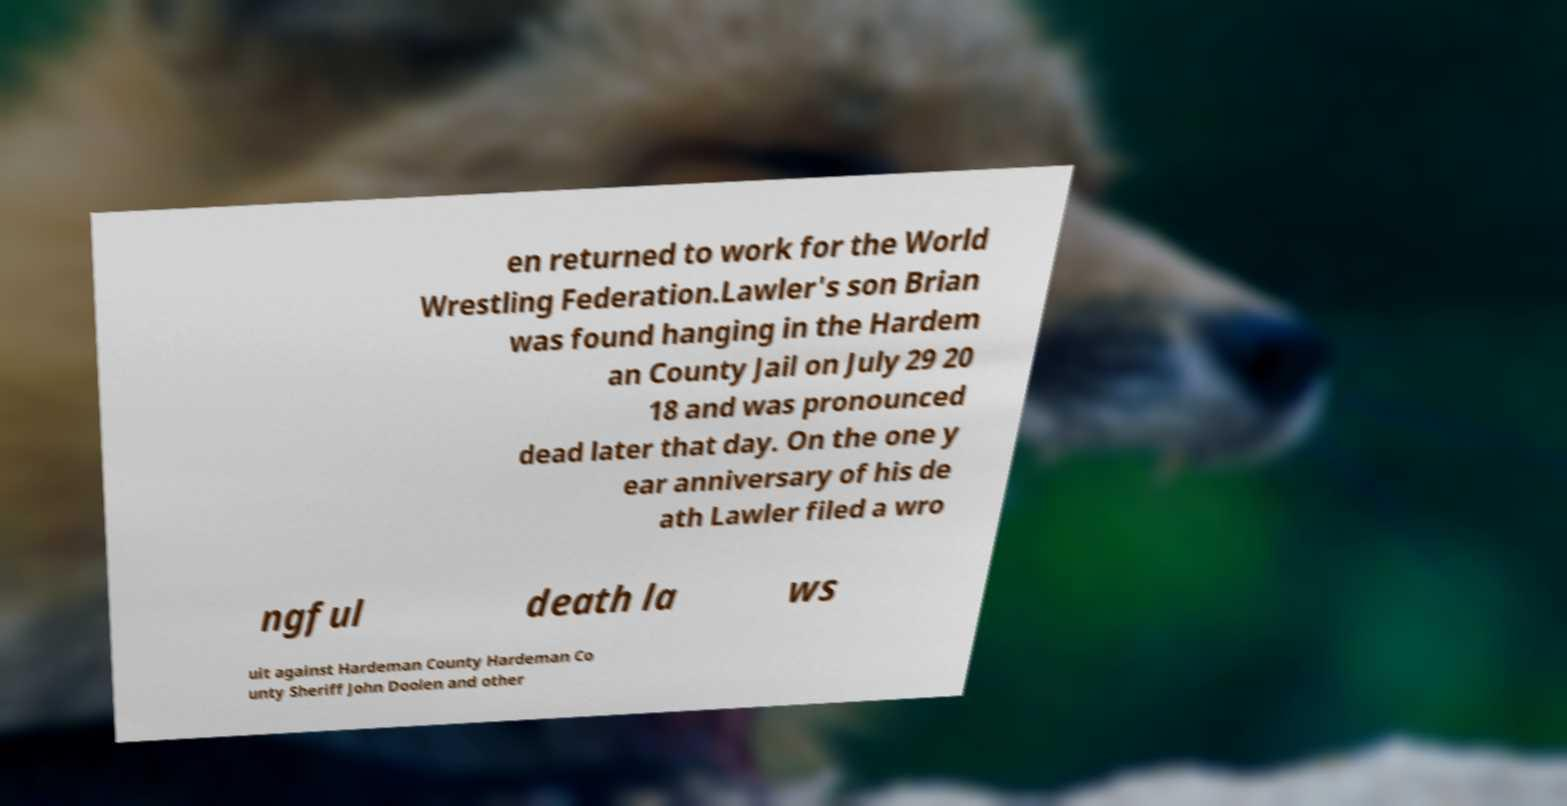There's text embedded in this image that I need extracted. Can you transcribe it verbatim? en returned to work for the World Wrestling Federation.Lawler's son Brian was found hanging in the Hardem an County Jail on July 29 20 18 and was pronounced dead later that day. On the one y ear anniversary of his de ath Lawler filed a wro ngful death la ws uit against Hardeman County Hardeman Co unty Sheriff John Doolen and other 